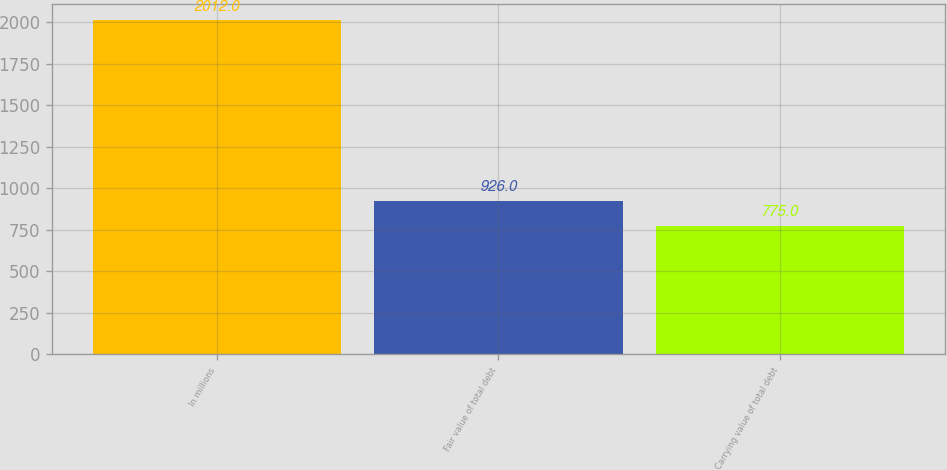Convert chart to OTSL. <chart><loc_0><loc_0><loc_500><loc_500><bar_chart><fcel>In millions<fcel>Fair value of total debt<fcel>Carrying value of total debt<nl><fcel>2012<fcel>926<fcel>775<nl></chart> 